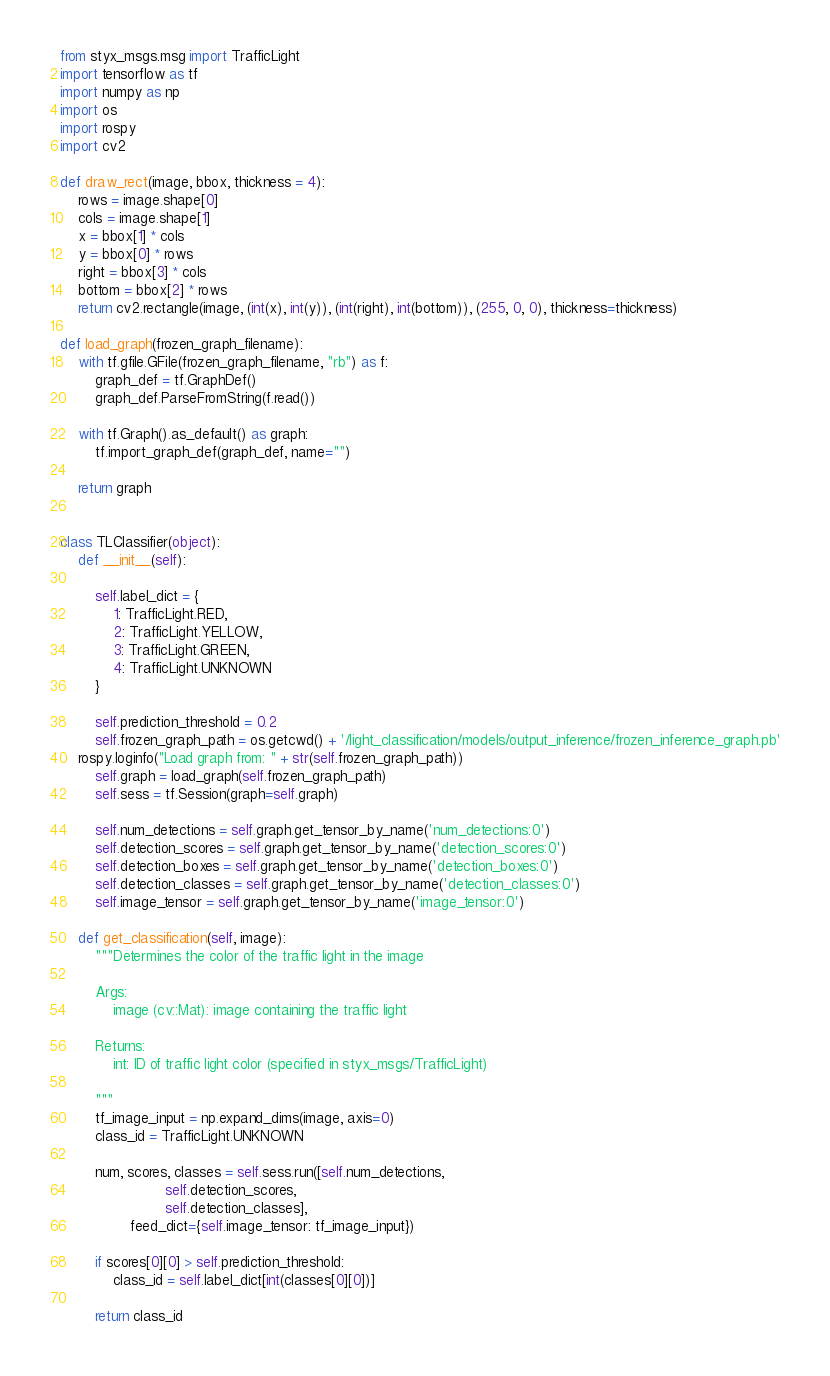Convert code to text. <code><loc_0><loc_0><loc_500><loc_500><_Python_>from styx_msgs.msg import TrafficLight
import tensorflow as tf
import numpy as np
import os
import rospy
import cv2

def draw_rect(image, bbox, thickness = 4):
    rows = image.shape[0]
    cols = image.shape[1]
    x = bbox[1] * cols
    y = bbox[0] * rows
    right = bbox[3] * cols
    bottom = bbox[2] * rows
    return cv2.rectangle(image, (int(x), int(y)), (int(right), int(bottom)), (255, 0, 0), thickness=thickness)

def load_graph(frozen_graph_filename):
    with tf.gfile.GFile(frozen_graph_filename, "rb") as f:
        graph_def = tf.GraphDef()
        graph_def.ParseFromString(f.read())

    with tf.Graph().as_default() as graph:
        tf.import_graph_def(graph_def, name="")

    return graph


class TLClassifier(object):
    def __init__(self):

        self.label_dict = {
            1: TrafficLight.RED,
            2: TrafficLight.YELLOW,
            3: TrafficLight.GREEN,
            4: TrafficLight.UNKNOWN
        }

        self.prediction_threshold = 0.2
        self.frozen_graph_path = os.getcwd() + '/light_classification/models/output_inference/frozen_inference_graph.pb'
	rospy.loginfo("Load graph from: " + str(self.frozen_graph_path))
        self.graph = load_graph(self.frozen_graph_path)
        self.sess = tf.Session(graph=self.graph)

        self.num_detections = self.graph.get_tensor_by_name('num_detections:0')
        self.detection_scores = self.graph.get_tensor_by_name('detection_scores:0')
        self.detection_boxes = self.graph.get_tensor_by_name('detection_boxes:0')
        self.detection_classes = self.graph.get_tensor_by_name('detection_classes:0')
        self.image_tensor = self.graph.get_tensor_by_name('image_tensor:0')

    def get_classification(self, image):
        """Determines the color of the traffic light in the image

        Args:
            image (cv::Mat): image containing the traffic light

        Returns:
            int: ID of traffic light color (specified in styx_msgs/TrafficLight)

        """
        tf_image_input = np.expand_dims(image, axis=0)
        class_id = TrafficLight.UNKNOWN

        num, scores, classes = self.sess.run([self.num_detections,
						self.detection_scores,
						self.detection_classes],
                feed_dict={self.image_tensor: tf_image_input})

        if scores[0][0] > self.prediction_threshold:
            class_id = self.label_dict[int(classes[0][0])]

        return class_id
</code> 